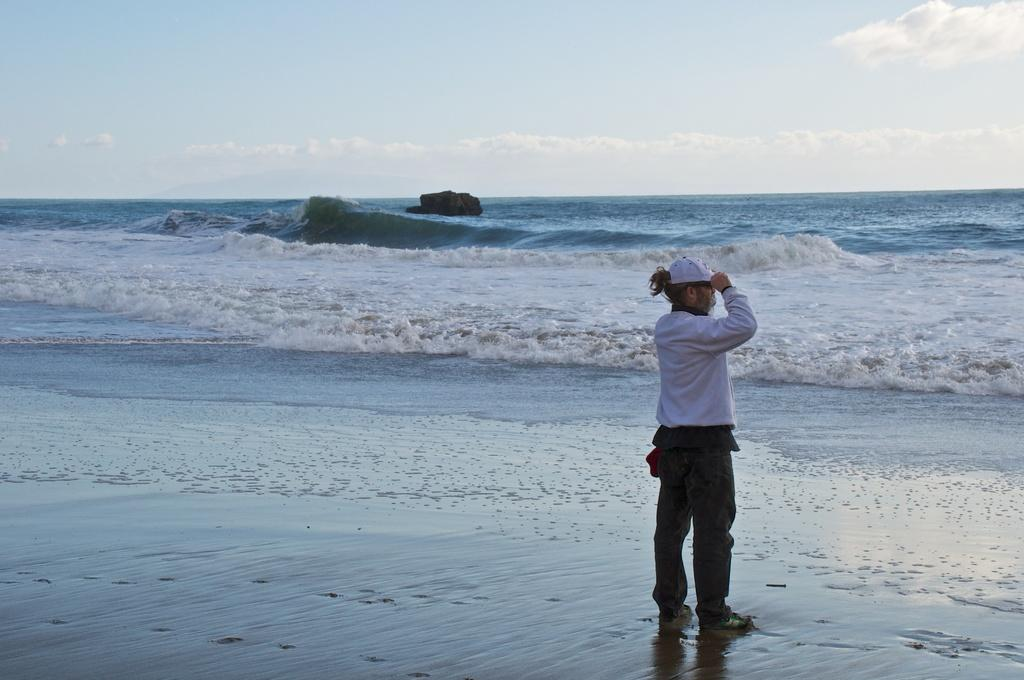What is the person in the image standing on? The person is standing on the sand. What else can be seen in the image besides the person? There is water visible in the image. What is visible in the background of the image? The sky is visible in the background of the image. What can be observed in the sky? Clouds are present in the sky. What type of book is the person reading on the sand? There is no book present in the image; the person is standing on the sand. How many clovers can be seen growing on the sand? There are no clovers visible in the image; the person is standing on sand near water. 